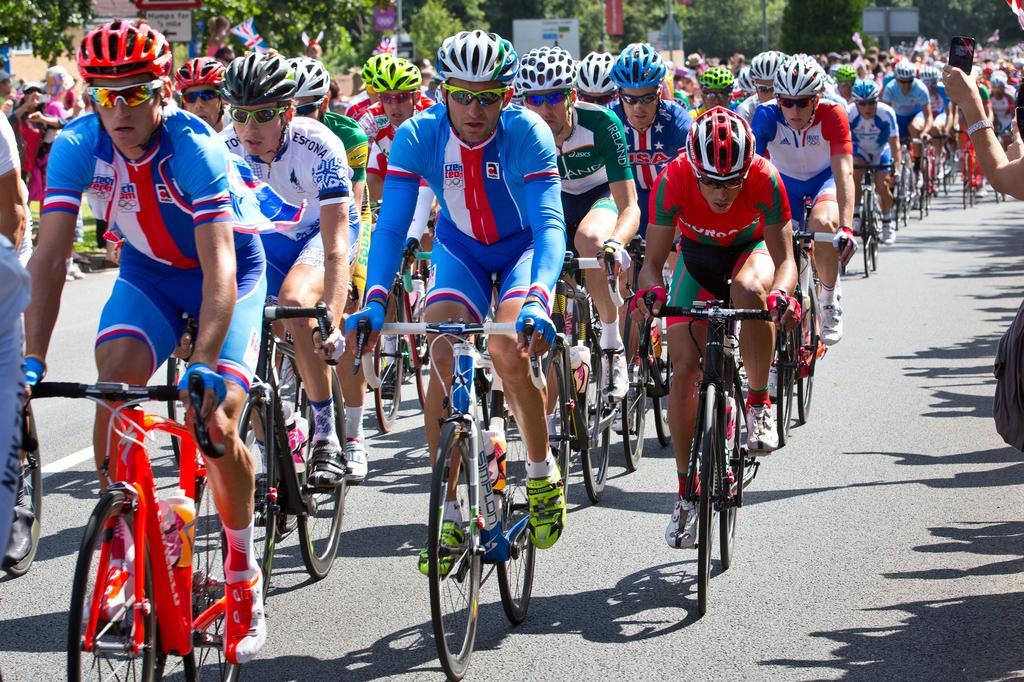In one or two sentences, can you explain what this image depicts? In this image we can see a group of people riding bicycles. Behind the people there are some trees, boards, flags and some people are standing. 